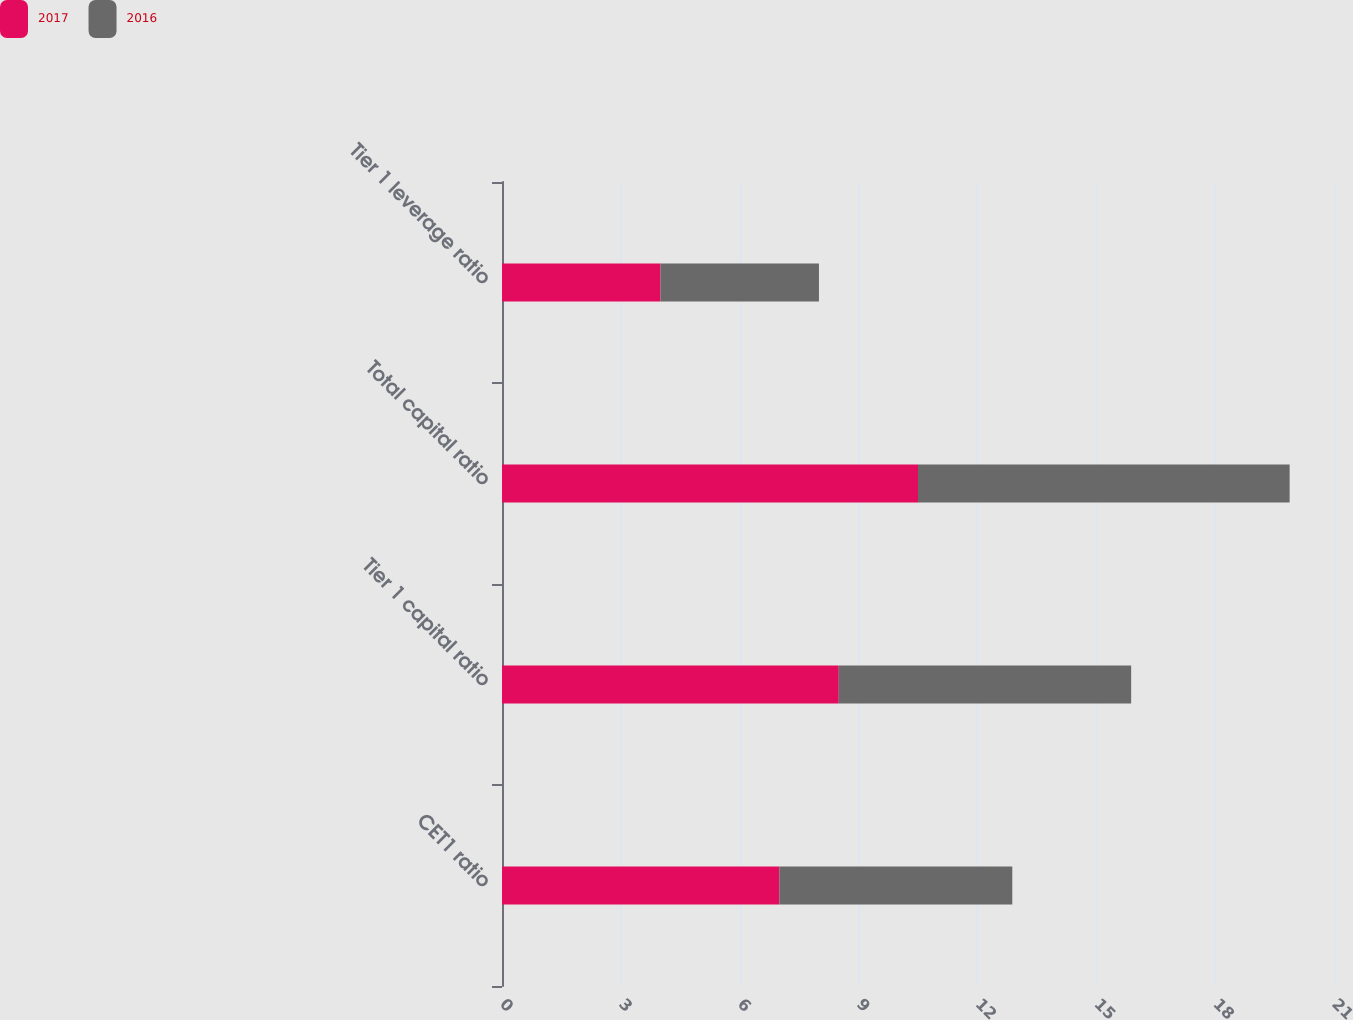Convert chart. <chart><loc_0><loc_0><loc_500><loc_500><stacked_bar_chart><ecel><fcel>CET1 ratio<fcel>Tier 1 capital ratio<fcel>Total capital ratio<fcel>Tier 1 leverage ratio<nl><fcel>2017<fcel>7<fcel>8.5<fcel>10.5<fcel>4<nl><fcel>2016<fcel>5.88<fcel>7.38<fcel>9.38<fcel>4<nl></chart> 